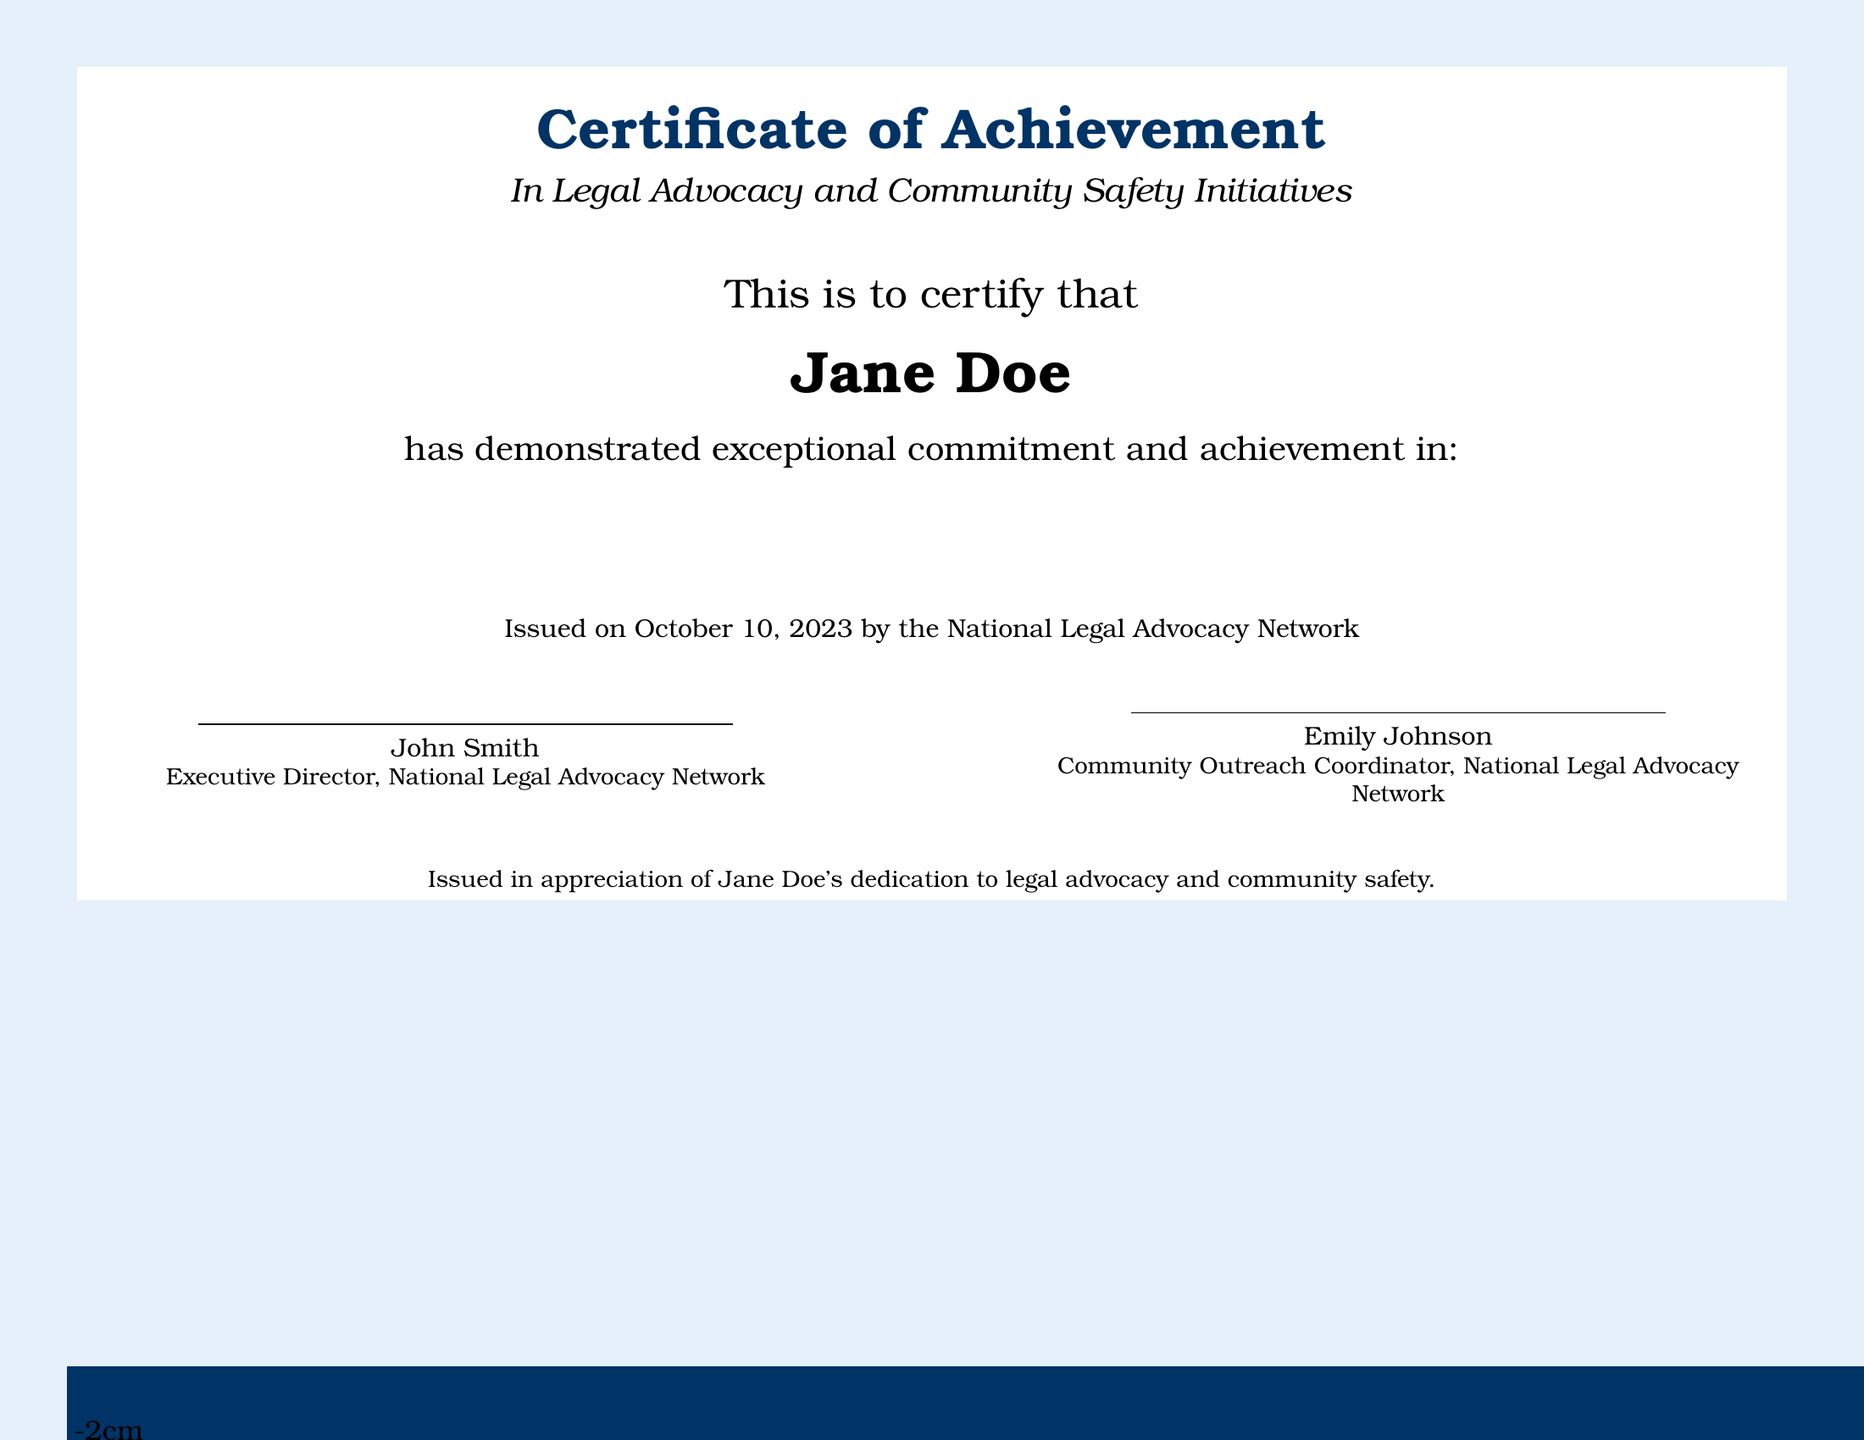What is the title of the certificate? The title of the certificate, as stated at the top of the document, is "Certificate of Achievement."
Answer: Certificate of Achievement Who is the recipient of the certificate? The recipient's name, prominently displayed in the document, is Jane Doe.
Answer: Jane Doe When was the certificate issued? The issuance date is mentioned near the end of the text as October 10, 2023.
Answer: October 10, 2023 What organization issued the certificate? The issuing organization is specified in the document as the National Legal Advocacy Network.
Answer: National Legal Advocacy Network What project did Jane Doe create for youth activism? One of the contributions listed is the creation of the 'Safe Space for Youth Activism' project.
Answer: Safe Space for Youth Activism Which two main areas are highlighted in Jane Doe's achievements? The two areas highlighted are Legal Advocacy and Community Safety Initiatives.
Answer: Legal Advocacy and Community Safety Initiatives Who signed the certificate? The certificate is signed by John Smith and Emily Johnson, as indicated in the signature lines.
Answer: John Smith and Emily Johnson What type of workshops did Jane Doe organize? The workshops organized by Jane Doe focused on legal rights and responsibilities for participants.
Answer: Workshops on legal rights and responsibilities What initiative was Jane Doe involved in promoting fair legal practices? The specific initiative mentioned is the 'Equal Justice Initiative.'
Answer: Equal Justice Initiative What role did Jane Doe play in the mentorship of young activists? Jane Doe's role included providing mentorship to young activists, as stated in the document.
Answer: Providing mentorship to young activists 